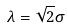Convert formula to latex. <formula><loc_0><loc_0><loc_500><loc_500>\lambda = \sqrt { 2 } \sigma</formula> 